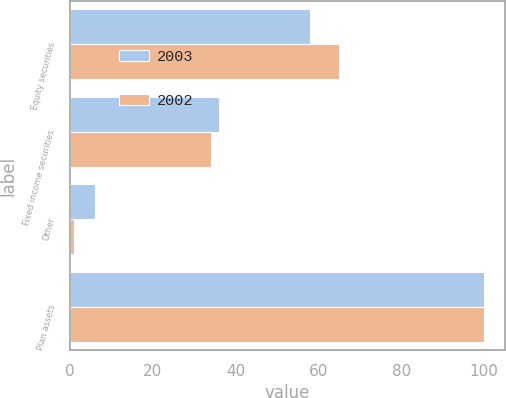<chart> <loc_0><loc_0><loc_500><loc_500><stacked_bar_chart><ecel><fcel>Equity securities<fcel>Fixed income securities<fcel>Other<fcel>Plan assets<nl><fcel>2003<fcel>58<fcel>36<fcel>6<fcel>100<nl><fcel>2002<fcel>65<fcel>34<fcel>1<fcel>100<nl></chart> 